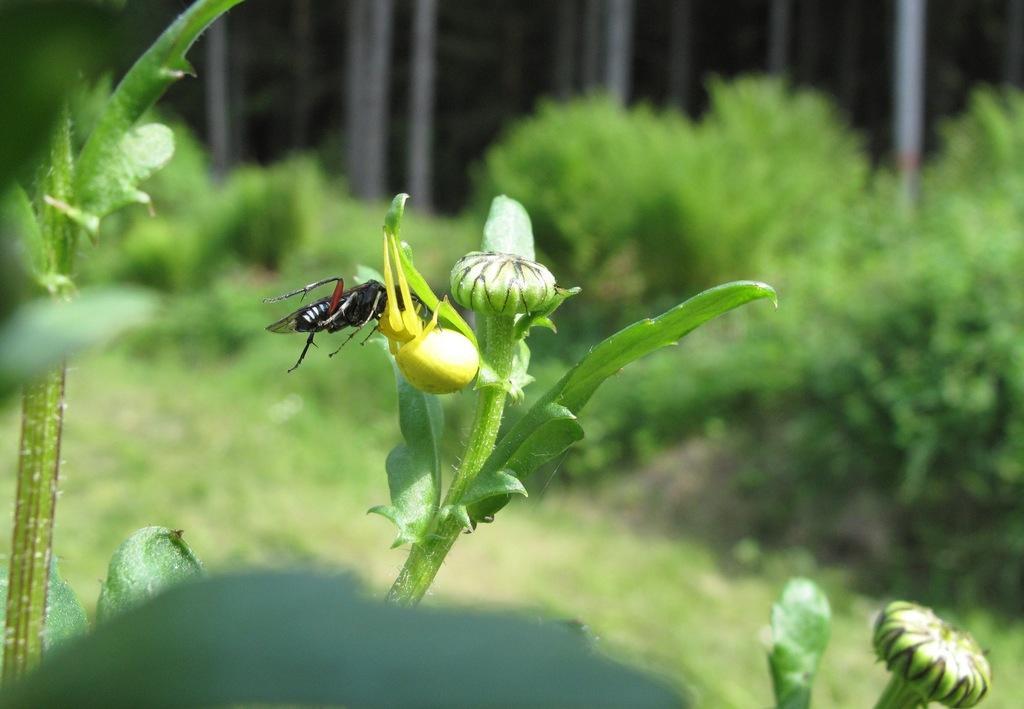Describe this image in one or two sentences. In this image an insect is on the bud of a plant having few leaves. Bottom of there are few plants having buds and ;leaves. Background there are few plants on the land. 